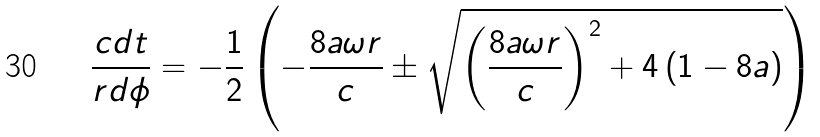Convert formula to latex. <formula><loc_0><loc_0><loc_500><loc_500>\frac { c d t } { r d \phi } = - \frac { 1 } { 2 } \left ( - \frac { 8 a \omega r } { c } \pm \sqrt { \left ( \frac { 8 a \omega r } { c } \right ) ^ { 2 } + 4 \left ( 1 - 8 a \right ) } \right )</formula> 